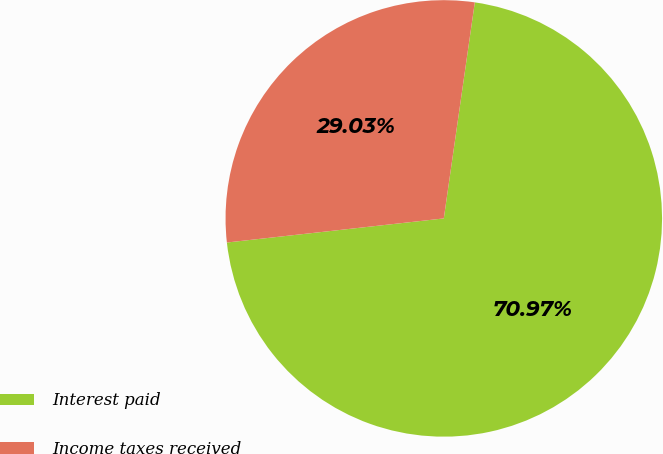<chart> <loc_0><loc_0><loc_500><loc_500><pie_chart><fcel>Interest paid<fcel>Income taxes received<nl><fcel>70.97%<fcel>29.03%<nl></chart> 